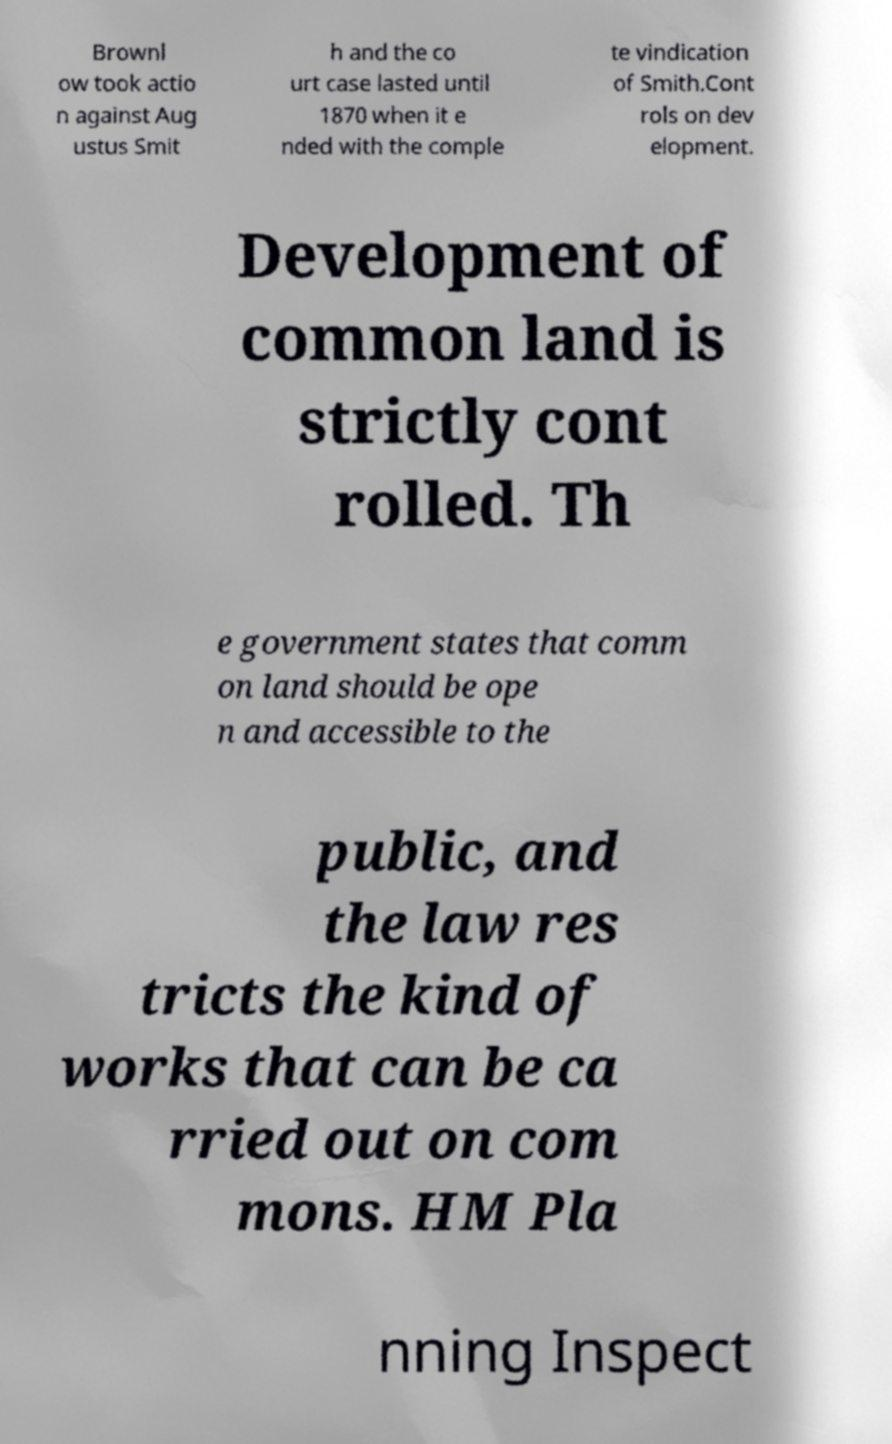Please read and relay the text visible in this image. What does it say? Brownl ow took actio n against Aug ustus Smit h and the co urt case lasted until 1870 when it e nded with the comple te vindication of Smith.Cont rols on dev elopment. Development of common land is strictly cont rolled. Th e government states that comm on land should be ope n and accessible to the public, and the law res tricts the kind of works that can be ca rried out on com mons. HM Pla nning Inspect 